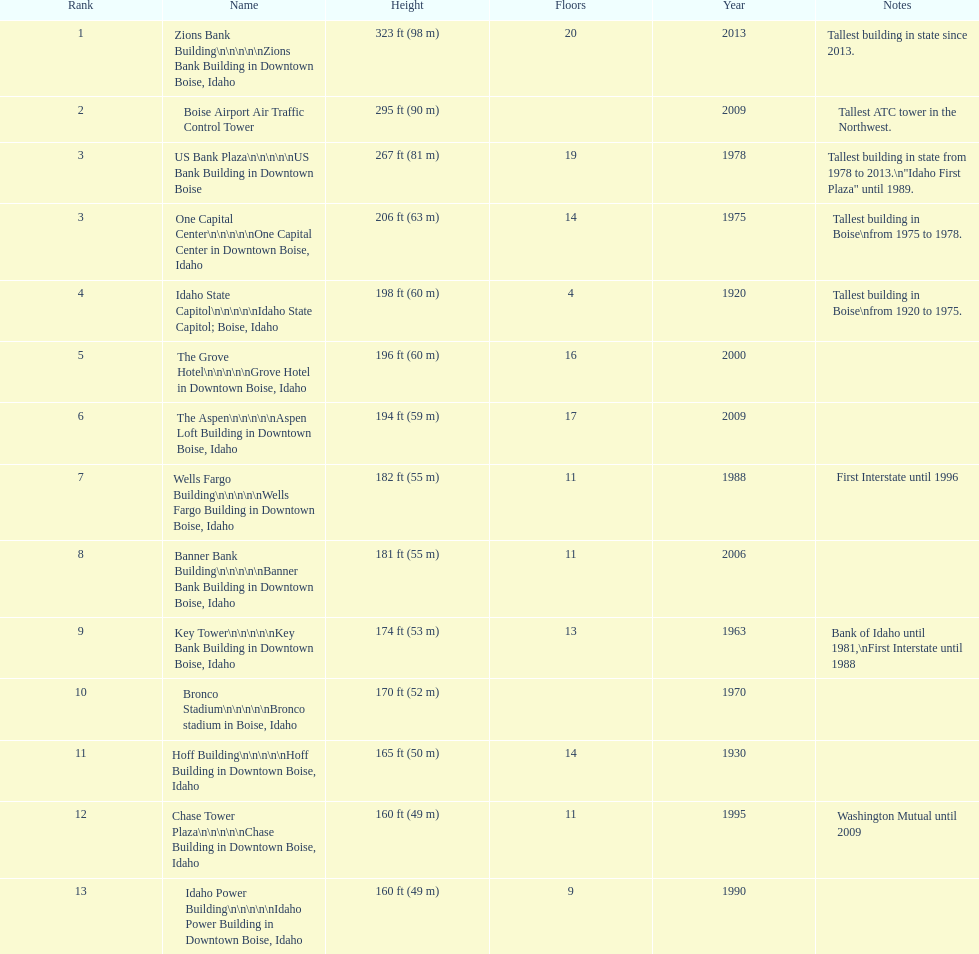What is the number of buildings constructed post-1975? 8. 